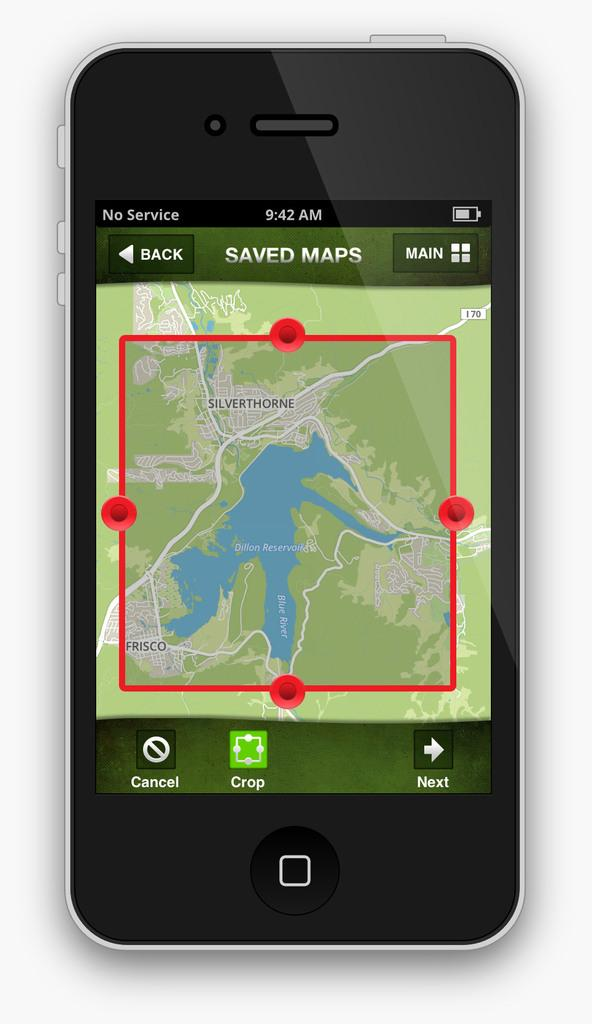<image>
Summarize the visual content of the image. A black phone with no service and a saved map open on its display. 